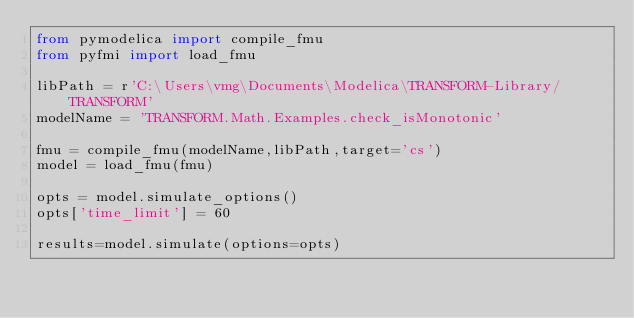Convert code to text. <code><loc_0><loc_0><loc_500><loc_500><_Python_>from pymodelica import compile_fmu
from pyfmi import load_fmu

libPath = r'C:\Users\vmg\Documents\Modelica\TRANSFORM-Library/TRANSFORM'
modelName = 'TRANSFORM.Math.Examples.check_isMonotonic'

fmu = compile_fmu(modelName,libPath,target='cs')
model = load_fmu(fmu)

opts = model.simulate_options()
opts['time_limit'] = 60

results=model.simulate(options=opts)
</code> 